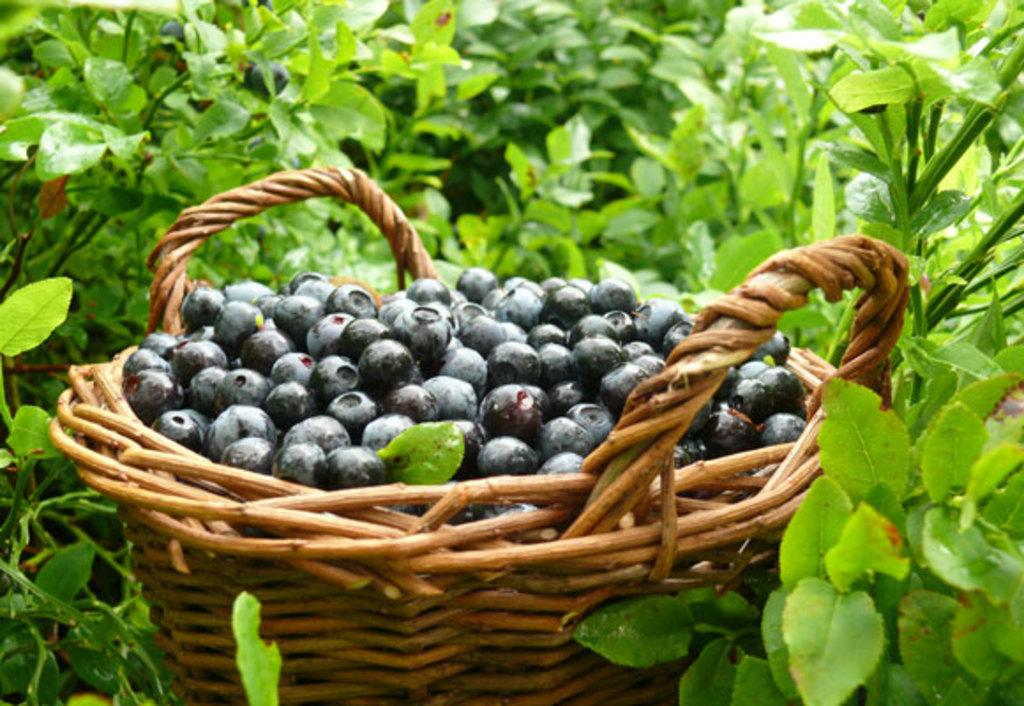What is in the basket that is visible in the image? There is a basket filled with berries in the image. Where is the basket located in the image? The basket is in the middle of the image. What can be seen in the background of the image? There are plants in the background of the image. What type of root can be seen growing from the berries in the image? There is no root growing from the berries in the image; the berries are contained within a basket. 